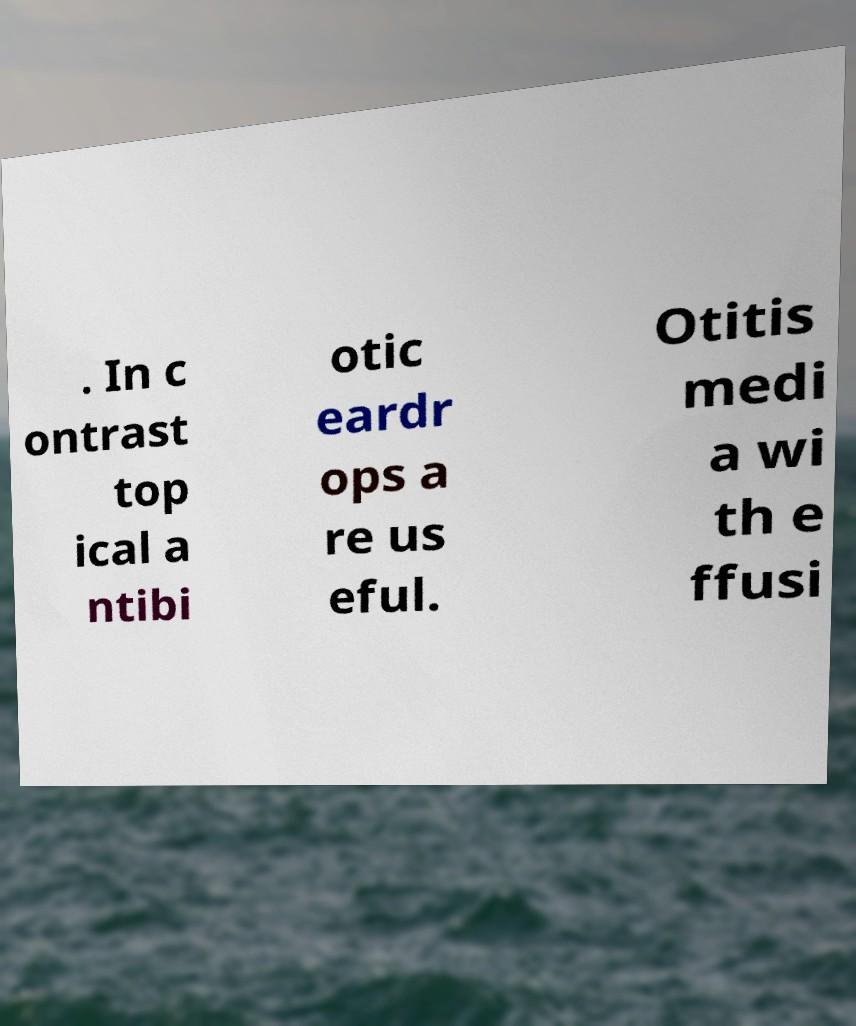Please identify and transcribe the text found in this image. . In c ontrast top ical a ntibi otic eardr ops a re us eful. Otitis medi a wi th e ffusi 